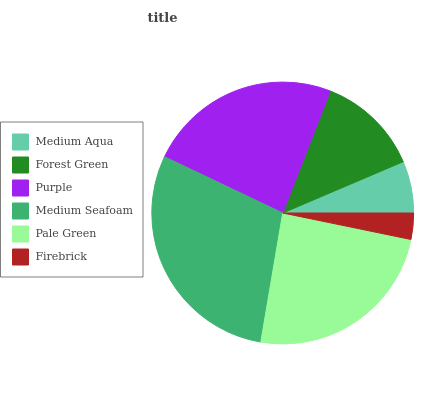Is Firebrick the minimum?
Answer yes or no. Yes. Is Medium Seafoam the maximum?
Answer yes or no. Yes. Is Forest Green the minimum?
Answer yes or no. No. Is Forest Green the maximum?
Answer yes or no. No. Is Forest Green greater than Medium Aqua?
Answer yes or no. Yes. Is Medium Aqua less than Forest Green?
Answer yes or no. Yes. Is Medium Aqua greater than Forest Green?
Answer yes or no. No. Is Forest Green less than Medium Aqua?
Answer yes or no. No. Is Purple the high median?
Answer yes or no. Yes. Is Forest Green the low median?
Answer yes or no. Yes. Is Pale Green the high median?
Answer yes or no. No. Is Medium Aqua the low median?
Answer yes or no. No. 